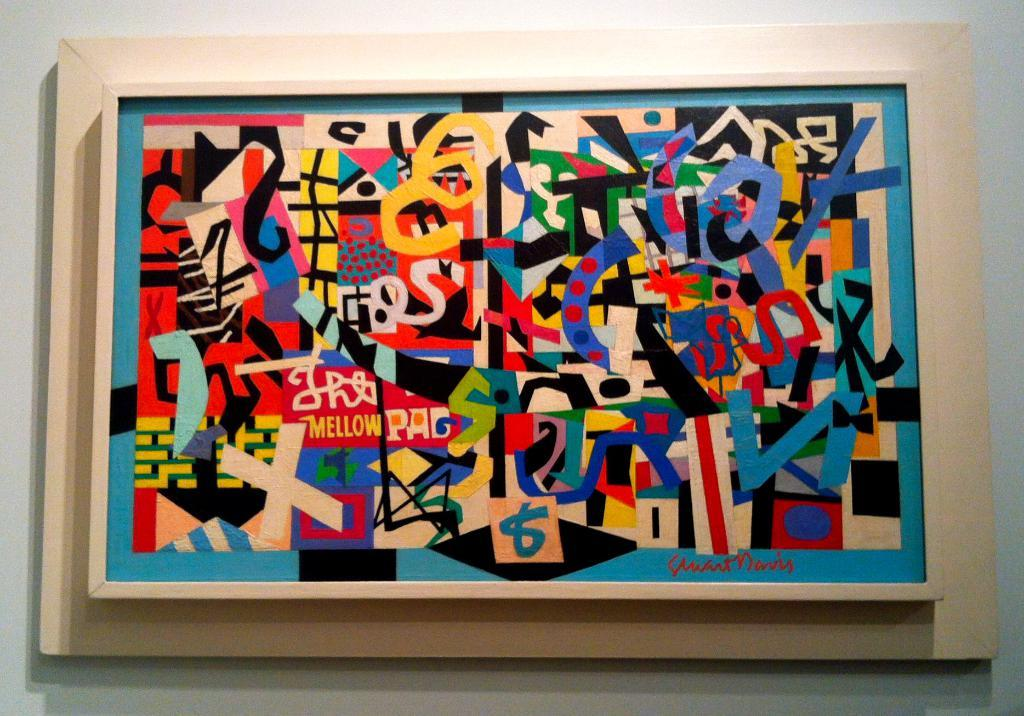<image>
Provide a brief description of the given image. A Mellow Pad painting hangs on the wall. 